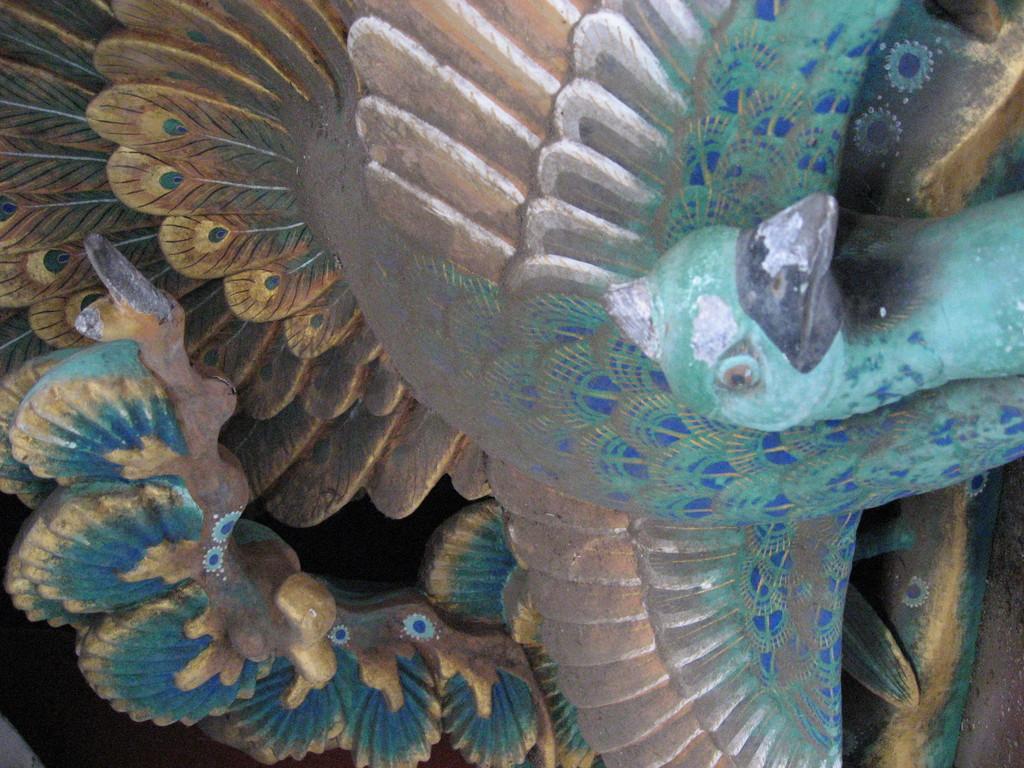Please provide a concise description of this image. In this image I can see a sculpture of a peacock with colorful design. 